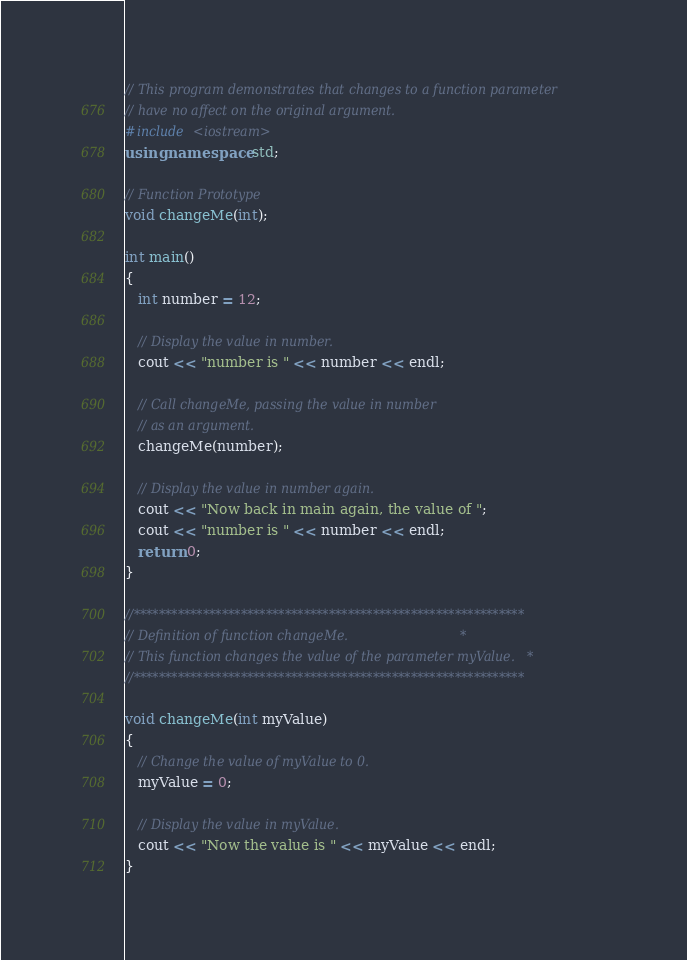<code> <loc_0><loc_0><loc_500><loc_500><_C++_>// This program demonstrates that changes to a function parameter
// have no affect on the original argument.
#include <iostream>
using namespace std;

// Function Prototype
void changeMe(int);

int main()
{
   int number = 12;

   // Display the value in number.
   cout << "number is " << number << endl;
   
   // Call changeMe, passing the value in number
   // as an argument.
   changeMe(number);
   
   // Display the value in number again.  
   cout << "Now back in main again, the value of ";
   cout << "number is " << number << endl;
   return 0;
}

//**************************************************************
// Definition of function changeMe.                            *
// This function changes the value of the parameter myValue.   *
//**************************************************************

void changeMe(int myValue)
{
   // Change the value of myValue to 0.
   myValue = 0;
   
   // Display the value in myValue.
   cout << "Now the value is " << myValue << endl;
}</code> 